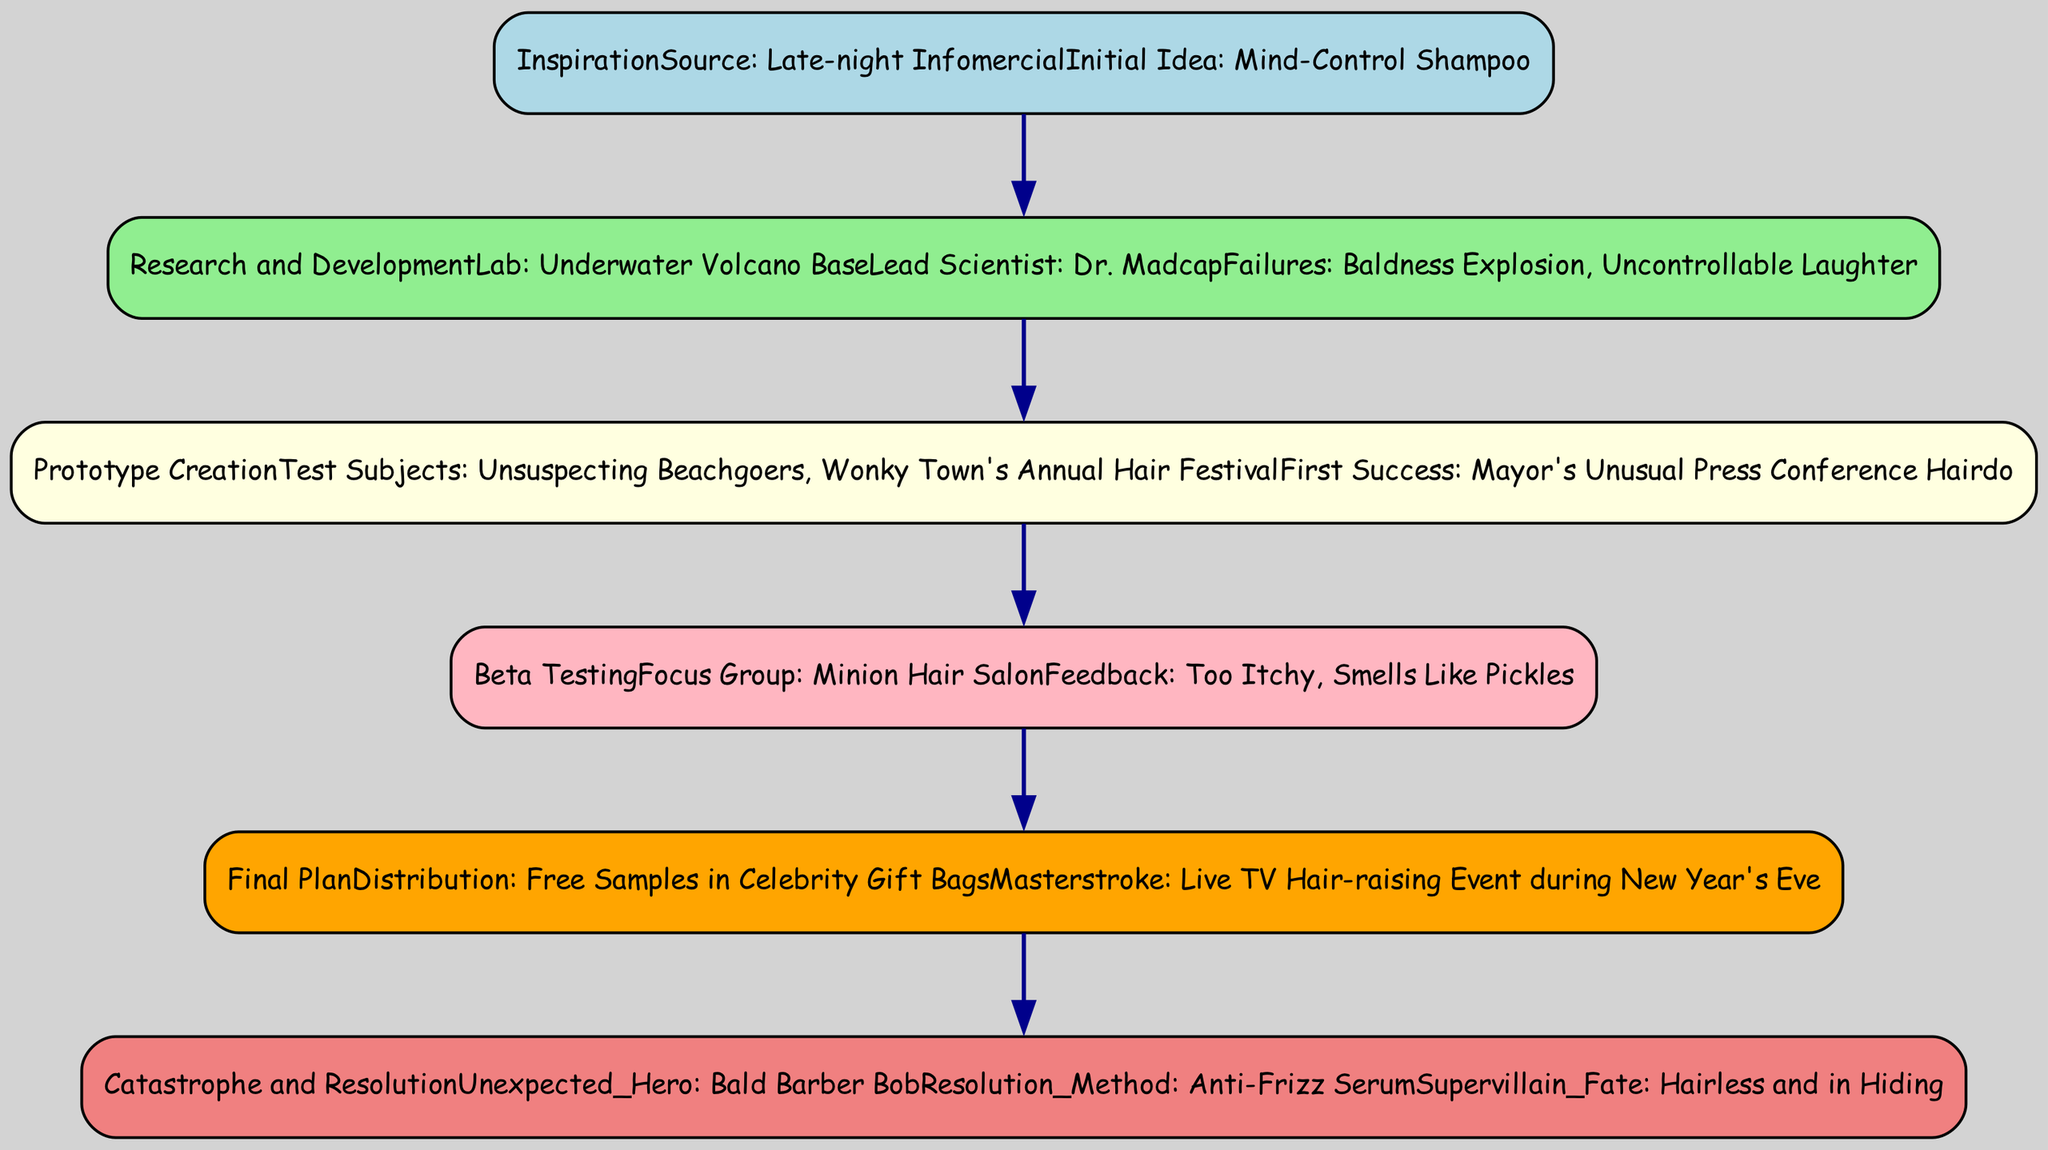What was the initial idea behind the supervillain's plan? The initial idea presented in the "Inspiration" node is "Mind-Control Shampoo."
Answer: Mind-Control Shampoo Who is the lead scientist in the research and development phase? This information is found in the "Research_and_Development" node where it states that the lead scientist is "Dr. Madcap."
Answer: Dr. Madcap What feedback did the focus group provide during beta testing? The feedback can be found in the "Beta_Testing" node, which includes "Too Itchy" and "Smells Like Pickles."
Answer: Too Itchy, Smells Like Pickles What was the masterstroke of the final plan? According to the "Final_Plan" node, the masterstroke was "Live TV Hair-raising Event during New Year's Eve."
Answer: Live TV Hair-raising Event during New Year's Eve What is the unexpected hero's name in the catastrophe phase? In the "Catastrophe_and_Resolution" node, the unexpected hero is named "Bald Barber Bob."
Answer: Bald Barber Bob How many failures were mentioned during the research and development phase? By reviewing the "Research_and_Development" node, it is noted that there are two failures listed: "Baldness Explosion" and "Uncontrollable Laughter."
Answer: 2 What color represents the research and development stage in the diagram? The diagram uses "lightgreen" to represent the "Research_and_Development" stage, as indicated in the color map for visual identification.
Answer: lightgreen What method was used to resolve the catastrophe? The resolution method in the "Catastrophe_and_Resolution" node is "Anti-Frizz Serum."
Answer: Anti-Frizz Serum Which test subjects were used for prototype creation? In the "Prototype_Creation" node, the test subjects included "Unsuspecting Beachgoers" and "Wonky Town's Annual Hair Festival."
Answer: Unsuspecting Beachgoers, Wonky Town's Annual Hair Festival 